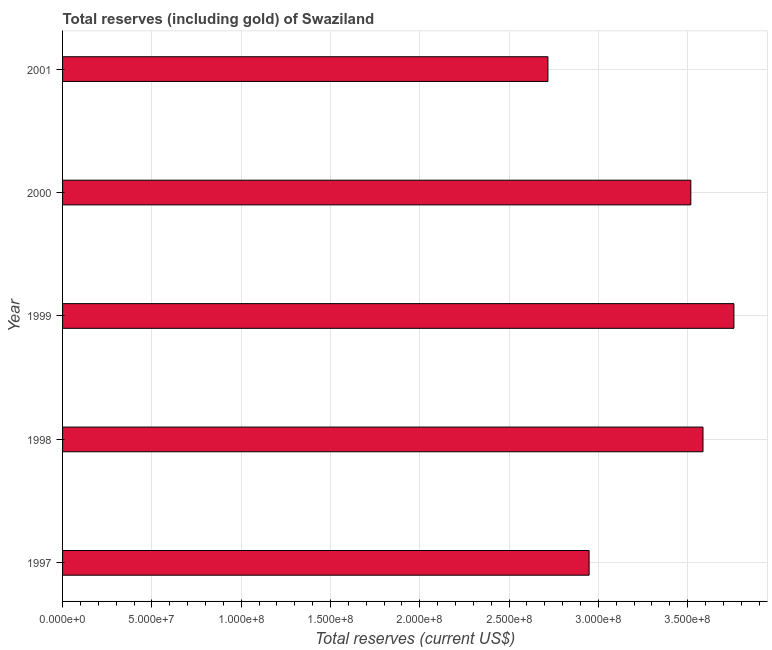Does the graph contain any zero values?
Make the answer very short. No. What is the title of the graph?
Offer a very short reply. Total reserves (including gold) of Swaziland. What is the label or title of the X-axis?
Your answer should be very brief. Total reserves (current US$). What is the label or title of the Y-axis?
Keep it short and to the point. Year. What is the total reserves (including gold) in 1997?
Make the answer very short. 2.95e+08. Across all years, what is the maximum total reserves (including gold)?
Your response must be concise. 3.76e+08. Across all years, what is the minimum total reserves (including gold)?
Provide a short and direct response. 2.72e+08. In which year was the total reserves (including gold) maximum?
Ensure brevity in your answer.  1999. In which year was the total reserves (including gold) minimum?
Give a very brief answer. 2001. What is the sum of the total reserves (including gold)?
Provide a succinct answer. 1.65e+09. What is the difference between the total reserves (including gold) in 1998 and 1999?
Offer a very short reply. -1.73e+07. What is the average total reserves (including gold) per year?
Ensure brevity in your answer.  3.31e+08. What is the median total reserves (including gold)?
Keep it short and to the point. 3.52e+08. In how many years, is the total reserves (including gold) greater than 280000000 US$?
Offer a very short reply. 4. Do a majority of the years between 1999 and 2000 (inclusive) have total reserves (including gold) greater than 160000000 US$?
Provide a succinct answer. Yes. What is the ratio of the total reserves (including gold) in 1997 to that in 1999?
Your answer should be very brief. 0.78. Is the total reserves (including gold) in 1998 less than that in 2000?
Keep it short and to the point. No. What is the difference between the highest and the second highest total reserves (including gold)?
Offer a terse response. 1.73e+07. What is the difference between the highest and the lowest total reserves (including gold)?
Provide a short and direct response. 1.04e+08. In how many years, is the total reserves (including gold) greater than the average total reserves (including gold) taken over all years?
Offer a very short reply. 3. How many years are there in the graph?
Your response must be concise. 5. What is the difference between two consecutive major ticks on the X-axis?
Offer a very short reply. 5.00e+07. What is the Total reserves (current US$) of 1997?
Make the answer very short. 2.95e+08. What is the Total reserves (current US$) of 1998?
Your response must be concise. 3.59e+08. What is the Total reserves (current US$) in 1999?
Your answer should be very brief. 3.76e+08. What is the Total reserves (current US$) in 2000?
Ensure brevity in your answer.  3.52e+08. What is the Total reserves (current US$) of 2001?
Make the answer very short. 2.72e+08. What is the difference between the Total reserves (current US$) in 1997 and 1998?
Give a very brief answer. -6.38e+07. What is the difference between the Total reserves (current US$) in 1997 and 1999?
Provide a succinct answer. -8.11e+07. What is the difference between the Total reserves (current US$) in 1997 and 2000?
Keep it short and to the point. -5.70e+07. What is the difference between the Total reserves (current US$) in 1997 and 2001?
Your answer should be compact. 2.31e+07. What is the difference between the Total reserves (current US$) in 1998 and 1999?
Provide a short and direct response. -1.73e+07. What is the difference between the Total reserves (current US$) in 1998 and 2000?
Ensure brevity in your answer.  6.82e+06. What is the difference between the Total reserves (current US$) in 1998 and 2001?
Offer a terse response. 8.68e+07. What is the difference between the Total reserves (current US$) in 1999 and 2000?
Give a very brief answer. 2.41e+07. What is the difference between the Total reserves (current US$) in 1999 and 2001?
Give a very brief answer. 1.04e+08. What is the difference between the Total reserves (current US$) in 2000 and 2001?
Your answer should be compact. 8.00e+07. What is the ratio of the Total reserves (current US$) in 1997 to that in 1998?
Offer a terse response. 0.82. What is the ratio of the Total reserves (current US$) in 1997 to that in 1999?
Give a very brief answer. 0.78. What is the ratio of the Total reserves (current US$) in 1997 to that in 2000?
Your answer should be compact. 0.84. What is the ratio of the Total reserves (current US$) in 1997 to that in 2001?
Keep it short and to the point. 1.08. What is the ratio of the Total reserves (current US$) in 1998 to that in 1999?
Your answer should be compact. 0.95. What is the ratio of the Total reserves (current US$) in 1998 to that in 2001?
Provide a short and direct response. 1.32. What is the ratio of the Total reserves (current US$) in 1999 to that in 2000?
Your response must be concise. 1.07. What is the ratio of the Total reserves (current US$) in 1999 to that in 2001?
Provide a short and direct response. 1.38. What is the ratio of the Total reserves (current US$) in 2000 to that in 2001?
Offer a very short reply. 1.29. 